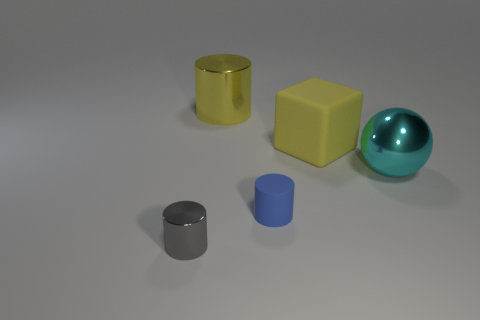Add 2 big shiny spheres. How many objects exist? 7 Subtract all big yellow cylinders. How many cylinders are left? 2 Subtract all gray cylinders. How many cylinders are left? 2 Subtract 2 cylinders. How many cylinders are left? 1 Subtract all small blue rubber things. Subtract all gray blocks. How many objects are left? 4 Add 4 yellow metallic cylinders. How many yellow metallic cylinders are left? 5 Add 5 large yellow things. How many large yellow things exist? 7 Subtract 0 purple balls. How many objects are left? 5 Subtract all cylinders. How many objects are left? 2 Subtract all purple cylinders. Subtract all purple spheres. How many cylinders are left? 3 